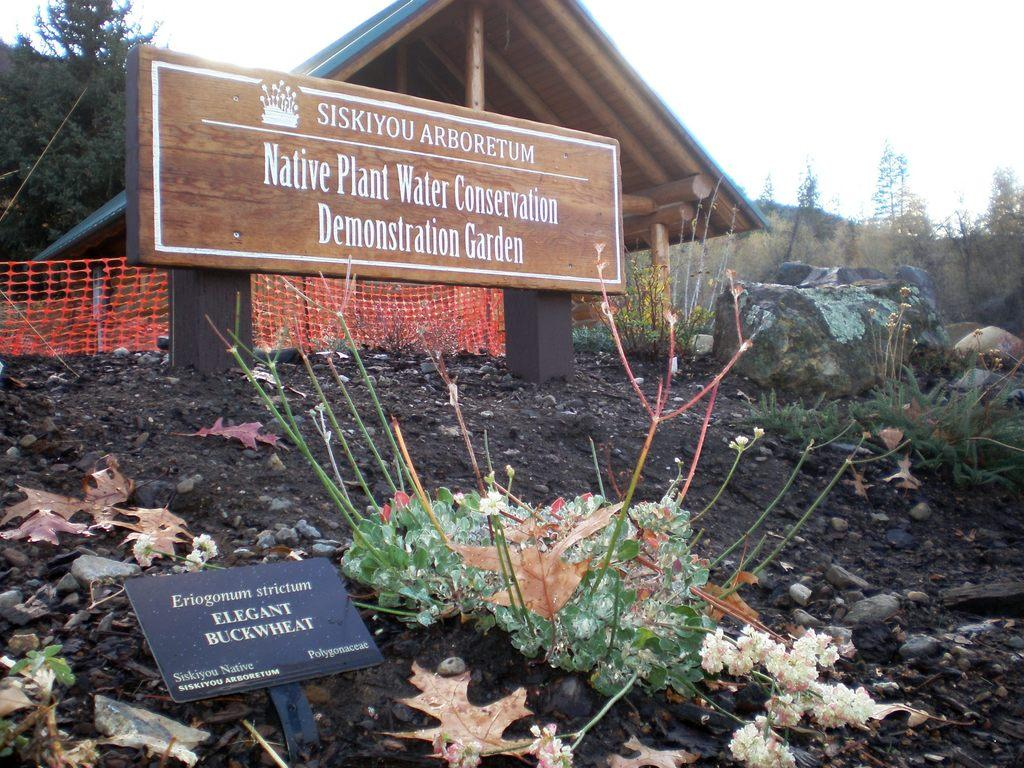What objects can be seen in the image that are made of wood? There are boards in the image that are made of wood. What type of natural vegetation is present in the image? There are trees in the image. What part of a building is visible in the image? The roof of a house is visible in the image. What is used to catch or hold objects in the image? There is a net in the image. Can you tell me which person in the image is smiling the most? There are no people present in the image, so it is not possible to determine who is smiling. 